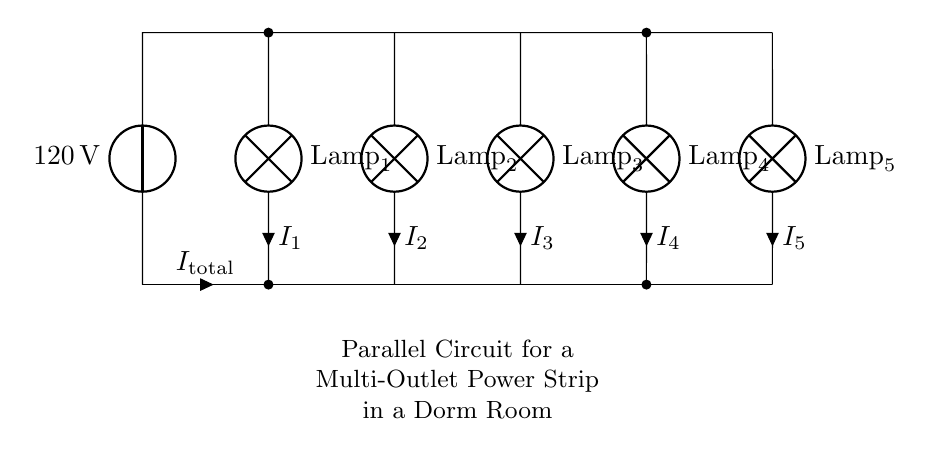What is the total voltage supplied to this circuit? The total voltage supplied to the circuit is indicated by the voltage source, which shows 120 volts at the top of the diagram.
Answer: 120 volts What type of components are used in this circuit? The circuit contains multiple lamps connected in parallel, which are the components depicted in the diagram clearly marked as Lamp 1, Lamp 2, Lamp 3, Lamp 4, and Lamp 5.
Answer: Lamps How many lamps are connected in this circuit? By counting the number of lamps shown in the circuit diagram, we see there are five lamps labeled sequentially from Lamp 1 to Lamp 5.
Answer: Five What is the current through Lamp 3? The current flowing through each lamp is denoted by i followed by the lamp number. For Lamp 3, it is indicated as I3, which represents its specific current.
Answer: I3 If one lamp fails, what happens to the other lamps? In a parallel circuit configuration, if one lamp fails, the remaining lamps will still operate because they have their own separate paths for current. The failure of one does not impact the others.
Answer: They still work What happens to the total current if more lamps are added? When more lamps are added in parallel, the total current will increase because each additional path allows for more current to flow in. Current is additive in parallel paths.
Answer: It increases What type of circuit configuration is shown in the diagram? The circuit has multiple components connected alongside each other, which is characteristic of a parallel circuit where each component has the same voltage across it.
Answer: Parallel 